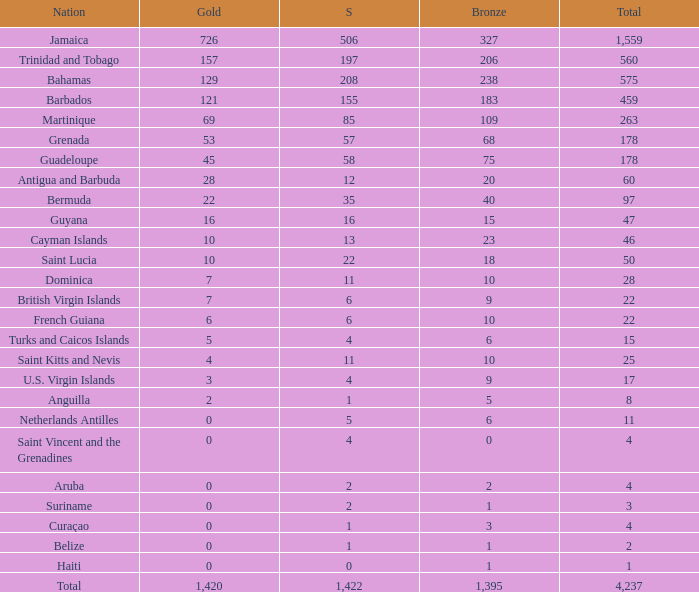What is listed as the highest Silver that also has a Gold of 4 and a Total that's larger than 25? None. 